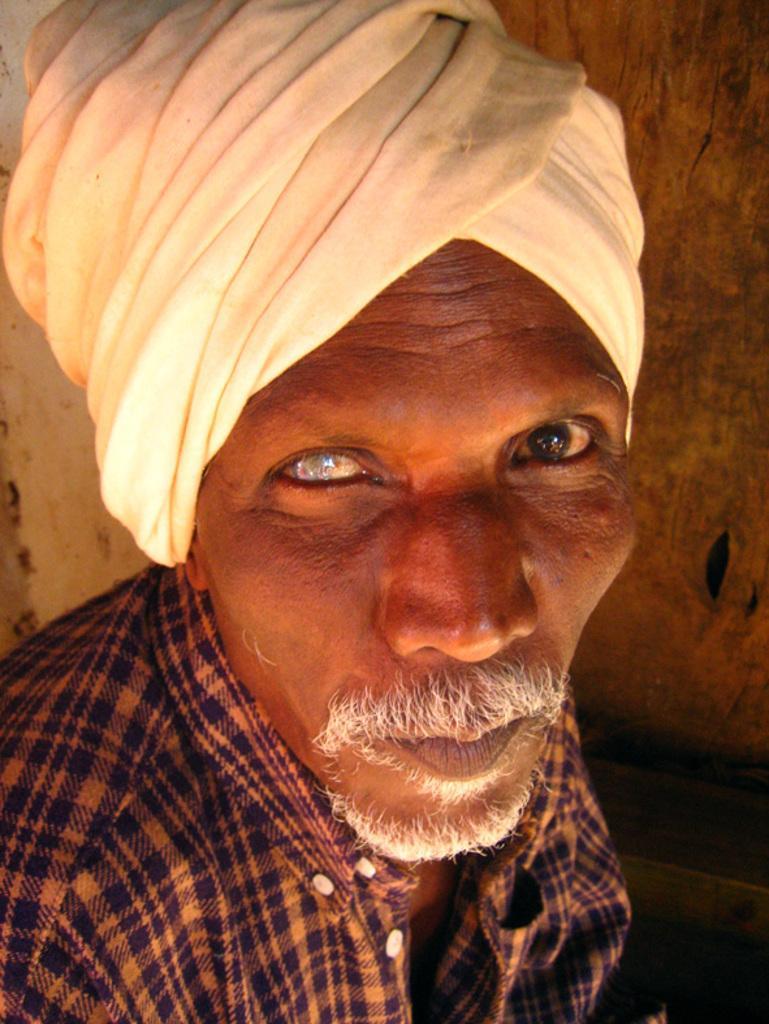Can you describe this image briefly? In this image there is an old man who is having a white turban. In the background there is a wall. 